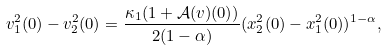<formula> <loc_0><loc_0><loc_500><loc_500>v _ { 1 } ^ { 2 } ( 0 ) - v _ { 2 } ^ { 2 } ( 0 ) = \frac { \kappa _ { 1 } ( 1 + \mathcal { A } ( v ) ( 0 ) ) } { 2 ( 1 - \alpha ) } ( x _ { 2 } ^ { 2 } ( 0 ) - x _ { 1 } ^ { 2 } ( 0 ) ) ^ { 1 - \alpha } ,</formula> 